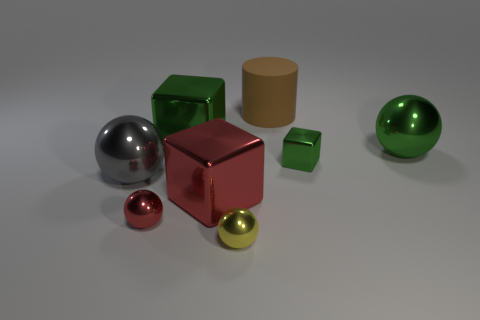Subtract all gray spheres. How many spheres are left? 3 Add 1 blocks. How many objects exist? 9 Subtract all red cylinders. How many green cubes are left? 2 Subtract all red balls. How many balls are left? 3 Subtract all red spheres. Subtract all yellow cylinders. How many spheres are left? 3 Subtract all cylinders. How many objects are left? 7 Subtract 1 spheres. How many spheres are left? 3 Subtract all tiny red rubber spheres. Subtract all brown cylinders. How many objects are left? 7 Add 4 small green shiny things. How many small green shiny things are left? 5 Add 5 big gray rubber cylinders. How many big gray rubber cylinders exist? 5 